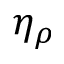<formula> <loc_0><loc_0><loc_500><loc_500>\eta _ { \rho }</formula> 